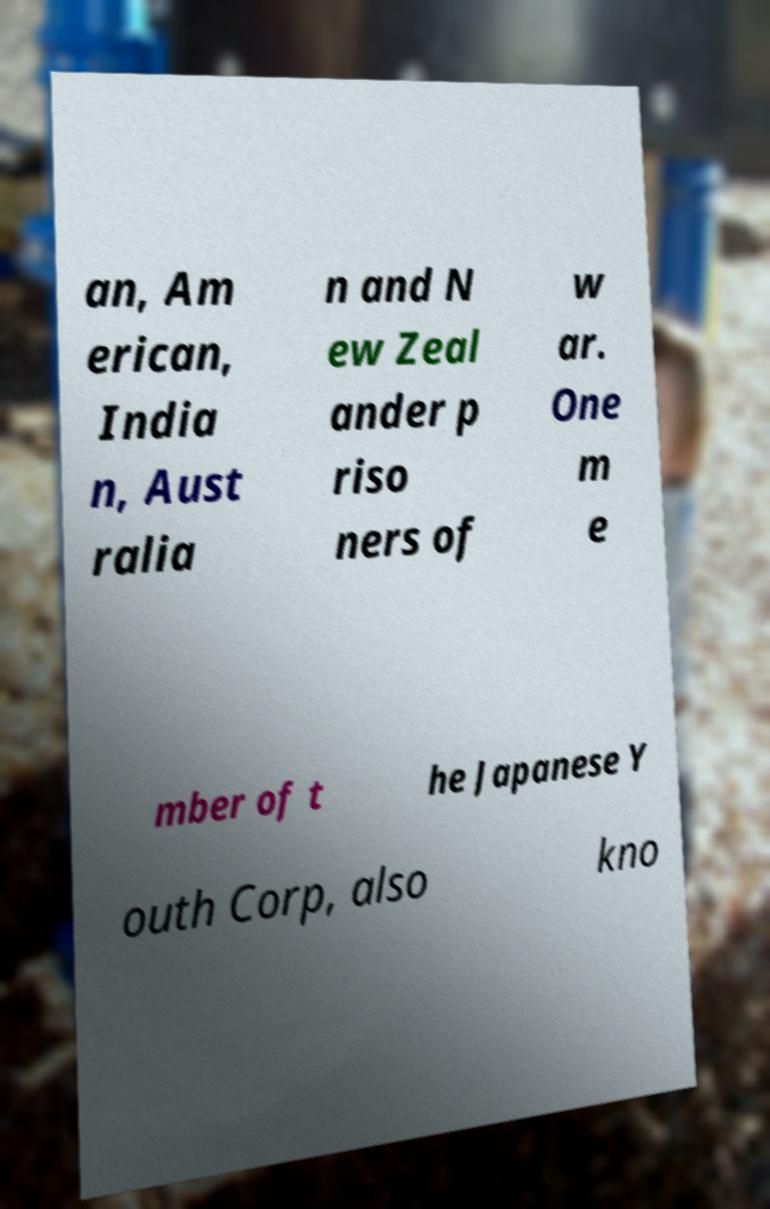I need the written content from this picture converted into text. Can you do that? an, Am erican, India n, Aust ralia n and N ew Zeal ander p riso ners of w ar. One m e mber of t he Japanese Y outh Corp, also kno 